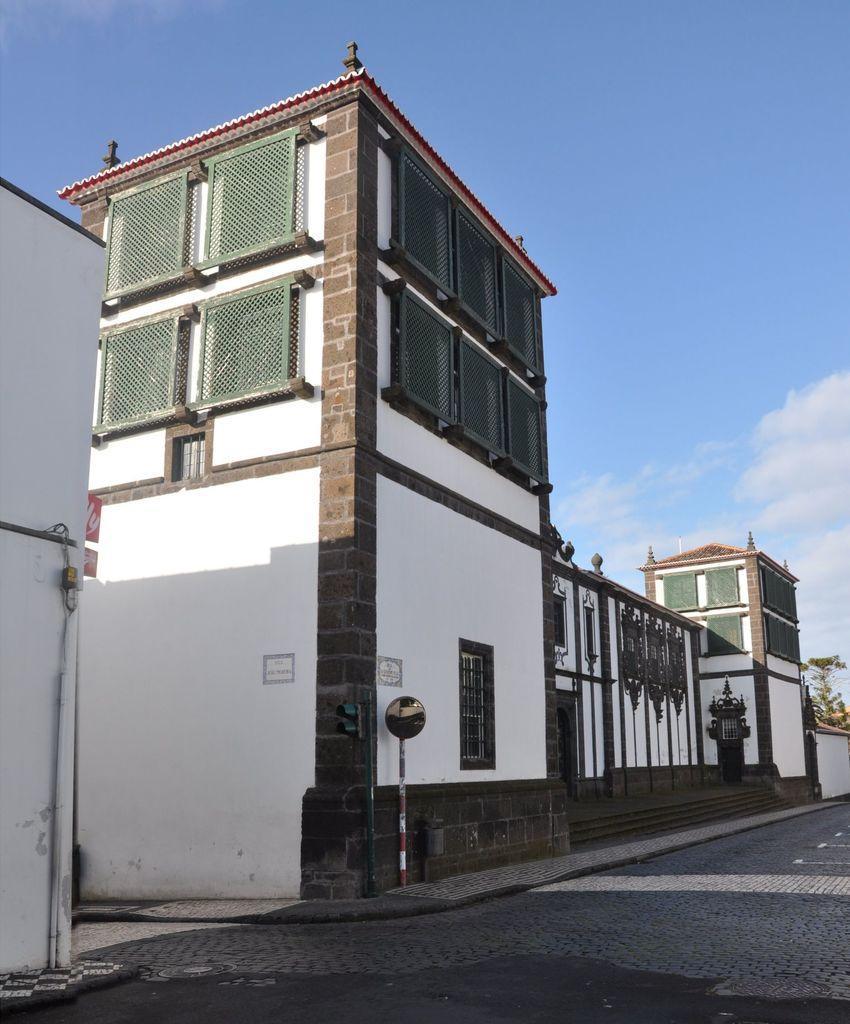Could you give a brief overview of what you see in this image? In this image I can see few buildings,windows,stairs,poles,traffic signal and green plants. The sky is in white and blue color. 